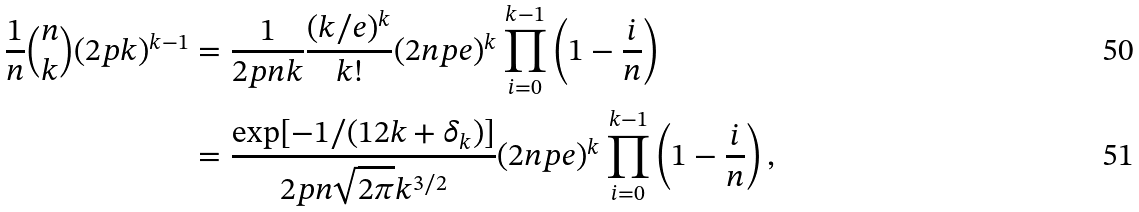<formula> <loc_0><loc_0><loc_500><loc_500>\frac { 1 } { n } \binom { n } { k } ( 2 p k ) ^ { k - 1 } & = \frac { 1 } { 2 p n k } \frac { ( k / e ) ^ { k } } { k ! } ( 2 n p e ) ^ { k } \prod _ { i = 0 } ^ { k - 1 } \left ( 1 - \frac { i } { n } \right ) \\ & = \frac { \exp [ - 1 / ( 1 2 k + \delta _ { k } ) ] } { 2 p n \sqrt { 2 \pi } k ^ { 3 / 2 } } ( 2 n p e ) ^ { k } \prod _ { i = 0 } ^ { k - 1 } \left ( 1 - \frac { i } { n } \right ) ,</formula> 